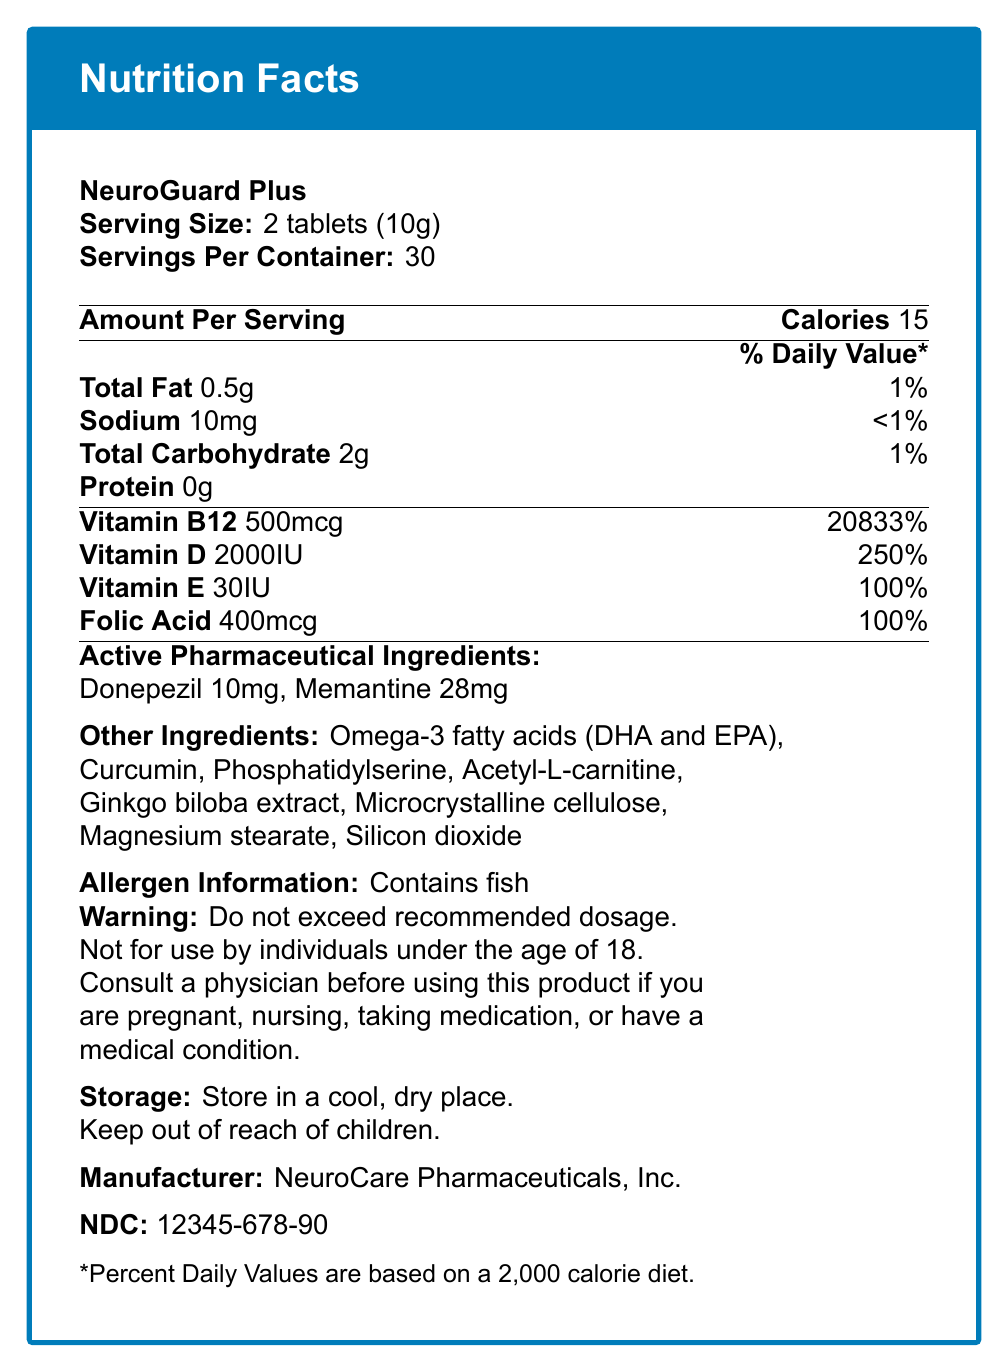what is the serving size of NeuroGuard Plus? The document states that the serving size of NeuroGuard Plus is 2 tablets (10g).
Answer: 2 tablets (10g) how many calories are in one serving of NeuroGuard Plus? The document specifies that there are 15 calories in one serving of NeuroGuard Plus.
Answer: 15 what is the percentage daily value of Vitamin B12 in NeuroGuard Plus? Vitamin B12 has a daily value of 20833% as mentioned in the document.
Answer: 20833% which pharmaceutical ingredient is present in a higher amount in NeuroGuard Plus, Donepezil or Memantine? Memantine is present in an amount of 28mg, whereas Donepezil is present in an amount of 10mg.
Answer: Memantine how many servings per container does NeuroGuard Plus have? The document states that there are 30 servings per container.
Answer: 30 which of the following vitamins is NOT listed in NeuroGuard Plus? A. Vitamin B12 B. Vitamin C C. Vitamin D D. Vitamin E The document lists Vitamin B12, Vitamin D, and Vitamin E, but not Vitamin C.
Answer: B what is the daily value percentage of sodium in NeuroGuard Plus? Sodium has a daily value percentage of less than 1% as per the document.
Answer: <1% how much Omega-3 fatty acids are present in NeuroGuard Plus? The document mentions Omega-3 fatty acids as an ingredient but does not specify the amount.
Answer: Cannot be determined is NeuroGuard Plus suitable for individuals under the age of 18? The warning section explicitly states that the product is not for use by individuals under the age of 18.
Answer: No which of the following ingredients is highlighted as a potential allergen? A. Soy B. Fish C. Gluten D. Nuts The allergen information section states that the product contains fish as a source of omega-3 fatty acids.
Answer: B what is the recommended dosage for NeuroGuard Plus? The dosage instructions specify taking 2 tablets daily, preferably with a meal or as directed by a healthcare professional.
Answer: Take 2 tablets daily, preferably with a meal or as directed by a healthcare professional does the document indicate that HealthGuard Plus has been evaluated by the FDA? The document includes a statement specifically saying that these statements have not been evaluated by the Food and Drug Administration.
Answer: No what is the main purpose of the document for NeuroGuard Plus? The document gives comprehensive information about the nutritional and pharmaceutical contents, dosage, warnings, storage, and manufacturer details of NeuroGuard Plus.
Answer: To provide nutritional and pharmaceutical information about the product, including serving size, ingredients, daily values, allergen information, warnings, dosage, and storage instructions. are the clinical trial results mentioned in the document for NeuroGuard Plus? The document mentions the results of a clinical trial involving 500 patients with mild to moderate Alzheimer's disease, showing statistically significant improvement in cognitive function and daily living activities compared to placebo.
Answer: Yes describe the main components and information found in the document about NeuroGuard Plus. The explanation summarizes the various sections and types of information present in the document, providing a comprehensive overview of both nutritional and pharmaceutical aspects of NeuroGuard Plus.
Answer: The document includes details about the product NeuroGuard Plus, such as serving size, servings per container, calories, macronutrient content, vitamins and minerals with their respective daily values and amounts, active pharmaceutical ingredients, other ingredients, allergen information, warnings, storage instructions, manufacturer information, FDA statement, clinical trial information, drug interactions, dosage instructions, and the NDC number. 